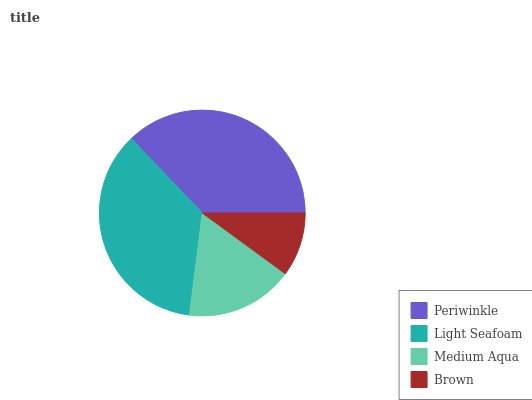Is Brown the minimum?
Answer yes or no. Yes. Is Periwinkle the maximum?
Answer yes or no. Yes. Is Light Seafoam the minimum?
Answer yes or no. No. Is Light Seafoam the maximum?
Answer yes or no. No. Is Periwinkle greater than Light Seafoam?
Answer yes or no. Yes. Is Light Seafoam less than Periwinkle?
Answer yes or no. Yes. Is Light Seafoam greater than Periwinkle?
Answer yes or no. No. Is Periwinkle less than Light Seafoam?
Answer yes or no. No. Is Light Seafoam the high median?
Answer yes or no. Yes. Is Medium Aqua the low median?
Answer yes or no. Yes. Is Periwinkle the high median?
Answer yes or no. No. Is Brown the low median?
Answer yes or no. No. 